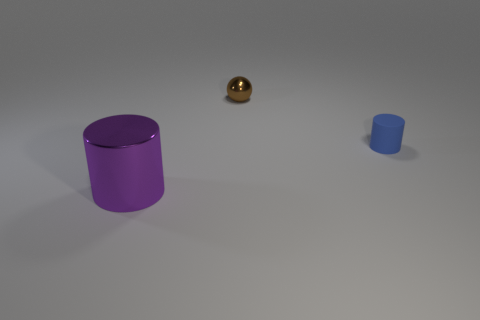Subtract all purple balls. Subtract all blue cylinders. How many balls are left? 1 Add 1 tiny balls. How many objects exist? 4 Subtract all cylinders. How many objects are left? 1 Add 1 tiny cyan rubber cylinders. How many tiny cyan rubber cylinders exist? 1 Subtract 0 gray spheres. How many objects are left? 3 Subtract all purple metallic cylinders. Subtract all big metal cylinders. How many objects are left? 1 Add 3 tiny brown objects. How many tiny brown objects are left? 4 